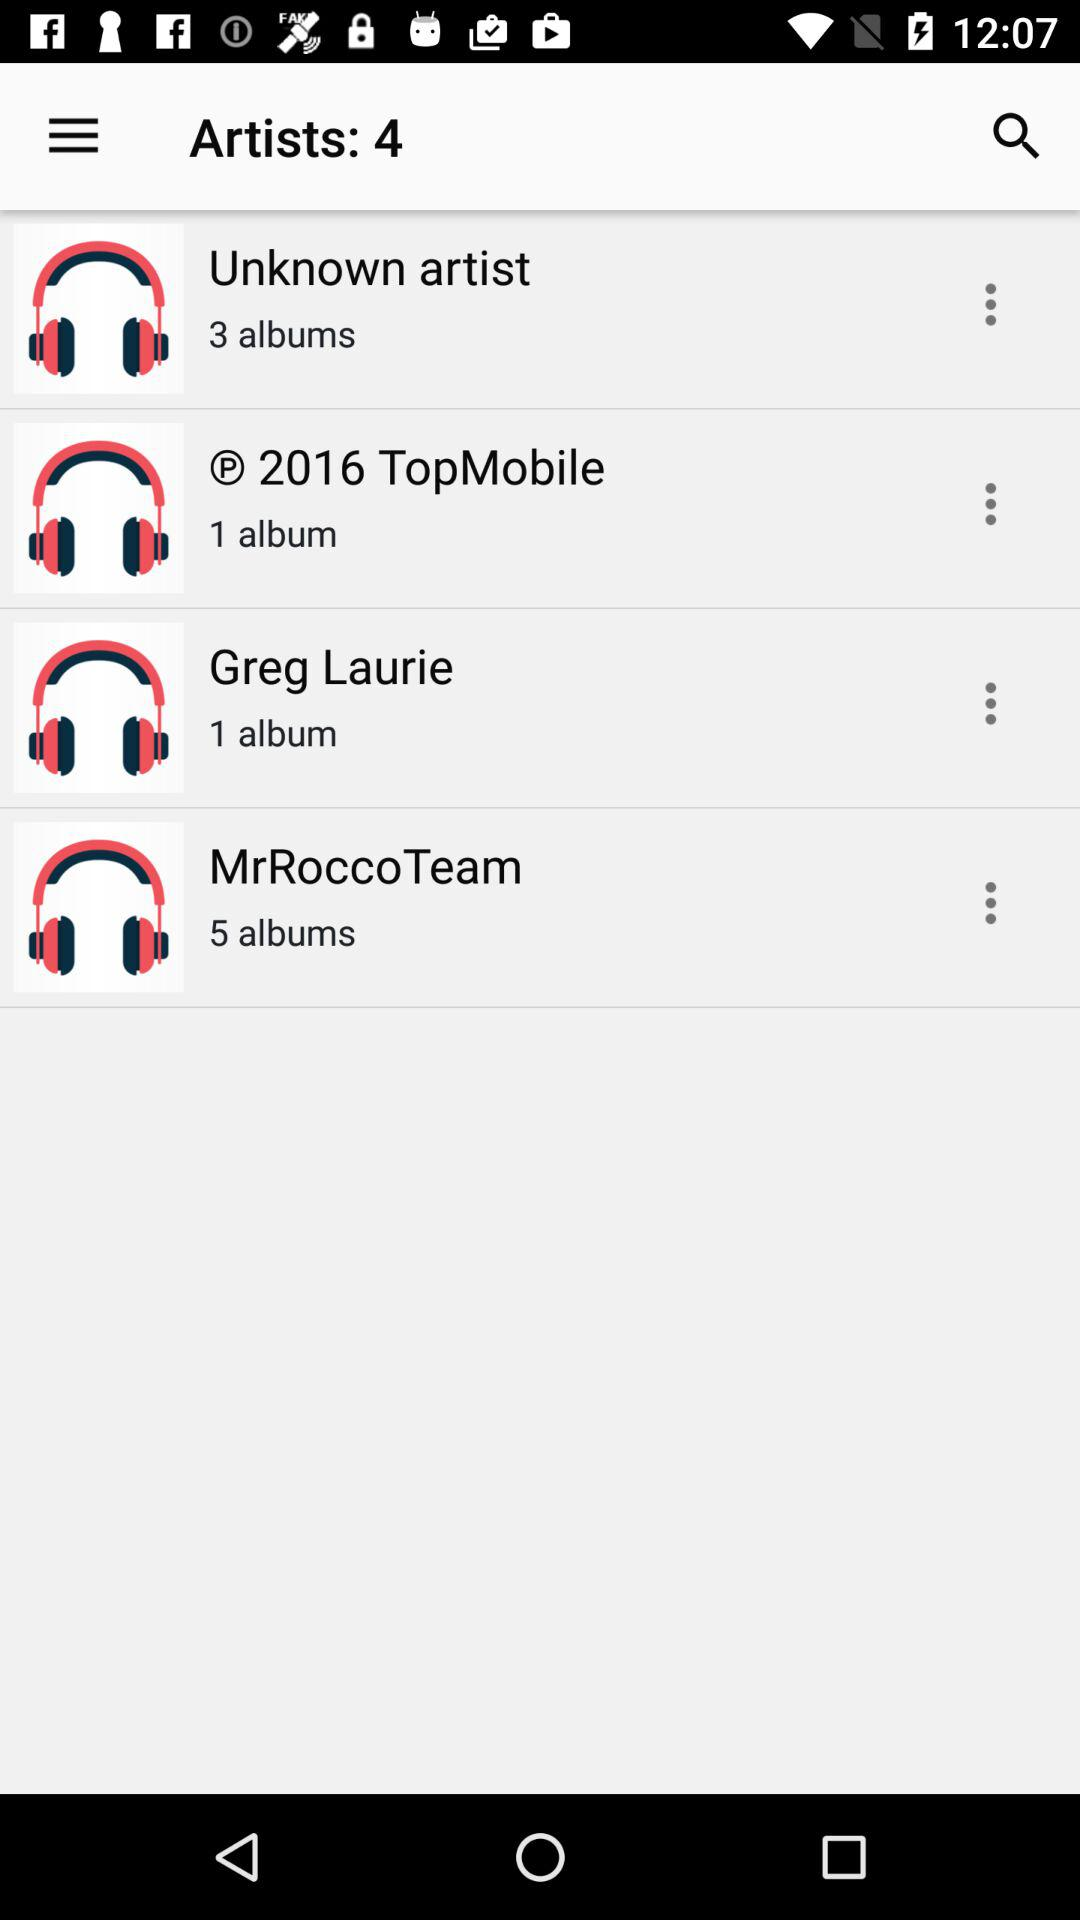What is the number of artists? The number of artists is 4. 